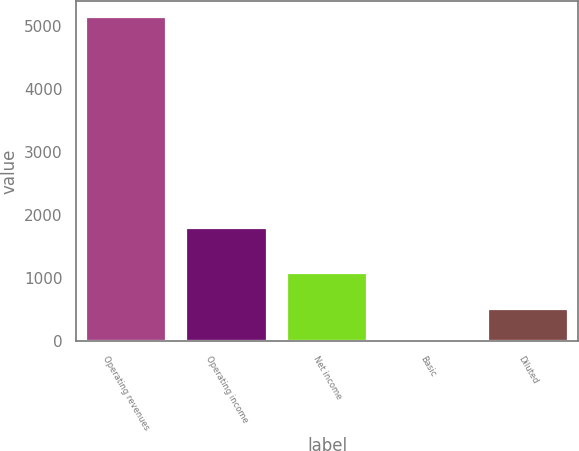Convert chart to OTSL. <chart><loc_0><loc_0><loc_500><loc_500><bar_chart><fcel>Operating revenues<fcel>Operating income<fcel>Net income<fcel>Basic<fcel>Diluted<nl><fcel>5132<fcel>1793<fcel>1072<fcel>1.32<fcel>514.39<nl></chart> 